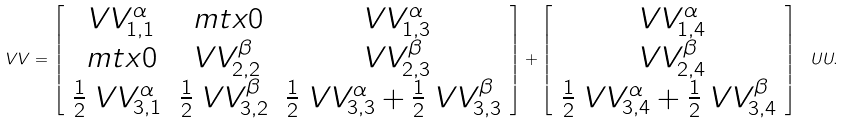<formula> <loc_0><loc_0><loc_500><loc_500>\ V V = \left [ \begin{array} { c c c } \ V V _ { 1 , 1 } ^ { \alpha } & \ m t x { 0 } & \ V V _ { 1 , 3 } ^ { \alpha } \\ \ m t x { 0 } & \ V V _ { 2 , 2 } ^ { \beta } & \ V V _ { 2 , 3 } ^ { \beta } \\ \frac { 1 } { 2 } \ V V _ { 3 , 1 } ^ { \alpha } & \frac { 1 } { 2 } \ V V _ { 3 , 2 } ^ { \beta } & \frac { 1 } { 2 } \ V V _ { 3 , 3 } ^ { \alpha } + \frac { 1 } { 2 } \ V V _ { 3 , 3 } ^ { \beta } \end{array} \right ] + \left [ \begin{array} { c } \ V V _ { 1 , 4 } ^ { \alpha } \\ \ V V _ { 2 , 4 } ^ { \beta } \\ \frac { 1 } { 2 } \ V V _ { 3 , 4 } ^ { \alpha } + \frac { 1 } { 2 } \ V V _ { 3 , 4 } ^ { \beta } \end{array} \right ] \, \ U U .</formula> 